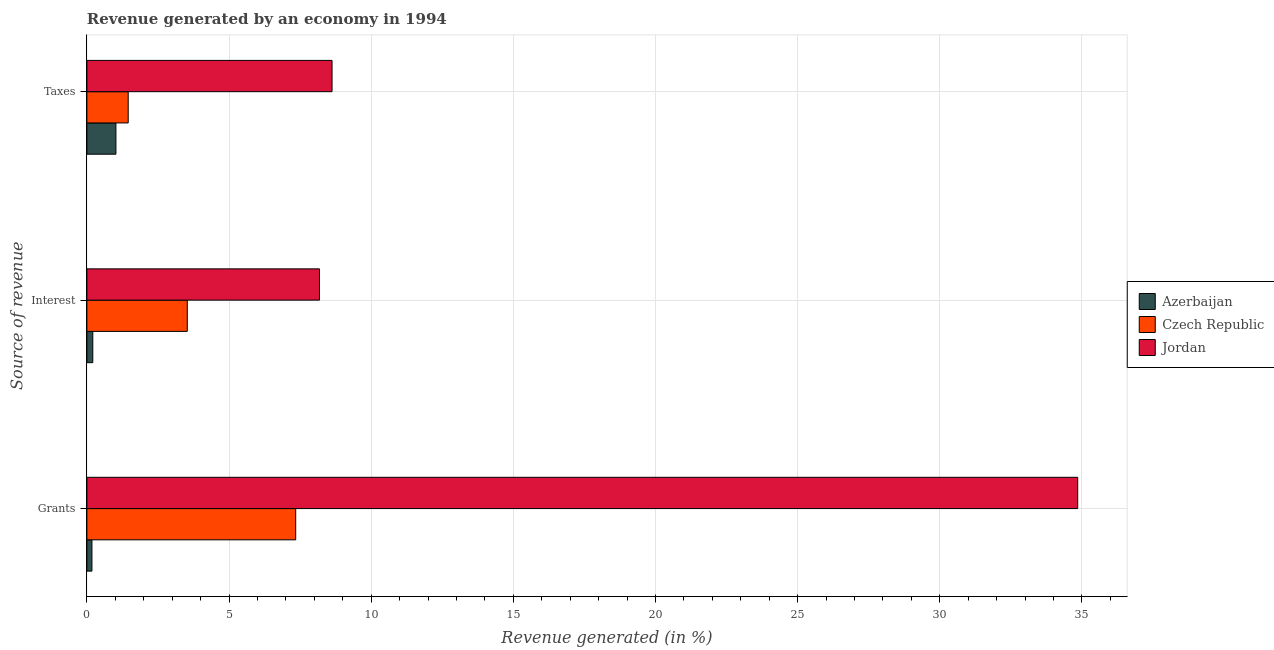How many different coloured bars are there?
Provide a succinct answer. 3. How many groups of bars are there?
Your response must be concise. 3. Are the number of bars per tick equal to the number of legend labels?
Provide a short and direct response. Yes. What is the label of the 3rd group of bars from the top?
Your answer should be compact. Grants. What is the percentage of revenue generated by grants in Jordan?
Provide a short and direct response. 34.85. Across all countries, what is the maximum percentage of revenue generated by interest?
Provide a succinct answer. 8.18. Across all countries, what is the minimum percentage of revenue generated by grants?
Your answer should be compact. 0.18. In which country was the percentage of revenue generated by taxes maximum?
Give a very brief answer. Jordan. In which country was the percentage of revenue generated by taxes minimum?
Keep it short and to the point. Azerbaijan. What is the total percentage of revenue generated by grants in the graph?
Your response must be concise. 42.38. What is the difference between the percentage of revenue generated by grants in Azerbaijan and that in Czech Republic?
Your response must be concise. -7.17. What is the difference between the percentage of revenue generated by taxes in Jordan and the percentage of revenue generated by grants in Azerbaijan?
Your answer should be very brief. 8.45. What is the average percentage of revenue generated by grants per country?
Ensure brevity in your answer.  14.13. What is the difference between the percentage of revenue generated by taxes and percentage of revenue generated by grants in Jordan?
Your answer should be compact. -26.23. In how many countries, is the percentage of revenue generated by taxes greater than 20 %?
Your response must be concise. 0. What is the ratio of the percentage of revenue generated by grants in Jordan to that in Czech Republic?
Provide a short and direct response. 4.74. Is the percentage of revenue generated by taxes in Czech Republic less than that in Jordan?
Ensure brevity in your answer.  Yes. What is the difference between the highest and the second highest percentage of revenue generated by interest?
Ensure brevity in your answer.  4.65. What is the difference between the highest and the lowest percentage of revenue generated by grants?
Offer a very short reply. 34.68. Is the sum of the percentage of revenue generated by interest in Czech Republic and Azerbaijan greater than the maximum percentage of revenue generated by taxes across all countries?
Provide a succinct answer. No. What does the 2nd bar from the top in Grants represents?
Offer a very short reply. Czech Republic. What does the 2nd bar from the bottom in Interest represents?
Your response must be concise. Czech Republic. How many bars are there?
Your response must be concise. 9. Are the values on the major ticks of X-axis written in scientific E-notation?
Your answer should be compact. No. Where does the legend appear in the graph?
Your response must be concise. Center right. How many legend labels are there?
Your answer should be compact. 3. What is the title of the graph?
Offer a terse response. Revenue generated by an economy in 1994. Does "Isle of Man" appear as one of the legend labels in the graph?
Your response must be concise. No. What is the label or title of the X-axis?
Make the answer very short. Revenue generated (in %). What is the label or title of the Y-axis?
Ensure brevity in your answer.  Source of revenue. What is the Revenue generated (in %) of Azerbaijan in Grants?
Your response must be concise. 0.18. What is the Revenue generated (in %) of Czech Republic in Grants?
Provide a short and direct response. 7.35. What is the Revenue generated (in %) in Jordan in Grants?
Your response must be concise. 34.85. What is the Revenue generated (in %) in Azerbaijan in Interest?
Keep it short and to the point. 0.21. What is the Revenue generated (in %) in Czech Republic in Interest?
Your response must be concise. 3.53. What is the Revenue generated (in %) of Jordan in Interest?
Keep it short and to the point. 8.18. What is the Revenue generated (in %) in Azerbaijan in Taxes?
Your response must be concise. 1.02. What is the Revenue generated (in %) in Czech Republic in Taxes?
Your response must be concise. 1.45. What is the Revenue generated (in %) in Jordan in Taxes?
Offer a very short reply. 8.62. Across all Source of revenue, what is the maximum Revenue generated (in %) in Azerbaijan?
Your answer should be very brief. 1.02. Across all Source of revenue, what is the maximum Revenue generated (in %) in Czech Republic?
Your response must be concise. 7.35. Across all Source of revenue, what is the maximum Revenue generated (in %) of Jordan?
Ensure brevity in your answer.  34.85. Across all Source of revenue, what is the minimum Revenue generated (in %) in Azerbaijan?
Offer a very short reply. 0.18. Across all Source of revenue, what is the minimum Revenue generated (in %) of Czech Republic?
Make the answer very short. 1.45. Across all Source of revenue, what is the minimum Revenue generated (in %) of Jordan?
Make the answer very short. 8.18. What is the total Revenue generated (in %) of Azerbaijan in the graph?
Your answer should be very brief. 1.41. What is the total Revenue generated (in %) in Czech Republic in the graph?
Offer a very short reply. 12.33. What is the total Revenue generated (in %) of Jordan in the graph?
Make the answer very short. 51.66. What is the difference between the Revenue generated (in %) in Azerbaijan in Grants and that in Interest?
Ensure brevity in your answer.  -0.03. What is the difference between the Revenue generated (in %) of Czech Republic in Grants and that in Interest?
Offer a very short reply. 3.81. What is the difference between the Revenue generated (in %) in Jordan in Grants and that in Interest?
Provide a succinct answer. 26.67. What is the difference between the Revenue generated (in %) of Azerbaijan in Grants and that in Taxes?
Your response must be concise. -0.84. What is the difference between the Revenue generated (in %) of Czech Republic in Grants and that in Taxes?
Ensure brevity in your answer.  5.89. What is the difference between the Revenue generated (in %) of Jordan in Grants and that in Taxes?
Your response must be concise. 26.23. What is the difference between the Revenue generated (in %) in Azerbaijan in Interest and that in Taxes?
Provide a short and direct response. -0.81. What is the difference between the Revenue generated (in %) of Czech Republic in Interest and that in Taxes?
Offer a very short reply. 2.08. What is the difference between the Revenue generated (in %) of Jordan in Interest and that in Taxes?
Give a very brief answer. -0.44. What is the difference between the Revenue generated (in %) in Azerbaijan in Grants and the Revenue generated (in %) in Czech Republic in Interest?
Give a very brief answer. -3.35. What is the difference between the Revenue generated (in %) in Azerbaijan in Grants and the Revenue generated (in %) in Jordan in Interest?
Make the answer very short. -8. What is the difference between the Revenue generated (in %) of Czech Republic in Grants and the Revenue generated (in %) of Jordan in Interest?
Provide a short and direct response. -0.84. What is the difference between the Revenue generated (in %) in Azerbaijan in Grants and the Revenue generated (in %) in Czech Republic in Taxes?
Keep it short and to the point. -1.28. What is the difference between the Revenue generated (in %) in Azerbaijan in Grants and the Revenue generated (in %) in Jordan in Taxes?
Your answer should be compact. -8.45. What is the difference between the Revenue generated (in %) in Czech Republic in Grants and the Revenue generated (in %) in Jordan in Taxes?
Provide a succinct answer. -1.28. What is the difference between the Revenue generated (in %) in Azerbaijan in Interest and the Revenue generated (in %) in Czech Republic in Taxes?
Offer a terse response. -1.25. What is the difference between the Revenue generated (in %) of Azerbaijan in Interest and the Revenue generated (in %) of Jordan in Taxes?
Your answer should be compact. -8.42. What is the difference between the Revenue generated (in %) in Czech Republic in Interest and the Revenue generated (in %) in Jordan in Taxes?
Ensure brevity in your answer.  -5.09. What is the average Revenue generated (in %) in Azerbaijan per Source of revenue?
Make the answer very short. 0.47. What is the average Revenue generated (in %) of Czech Republic per Source of revenue?
Give a very brief answer. 4.11. What is the average Revenue generated (in %) in Jordan per Source of revenue?
Provide a succinct answer. 17.22. What is the difference between the Revenue generated (in %) in Azerbaijan and Revenue generated (in %) in Czech Republic in Grants?
Ensure brevity in your answer.  -7.17. What is the difference between the Revenue generated (in %) of Azerbaijan and Revenue generated (in %) of Jordan in Grants?
Make the answer very short. -34.68. What is the difference between the Revenue generated (in %) in Czech Republic and Revenue generated (in %) in Jordan in Grants?
Make the answer very short. -27.51. What is the difference between the Revenue generated (in %) in Azerbaijan and Revenue generated (in %) in Czech Republic in Interest?
Keep it short and to the point. -3.32. What is the difference between the Revenue generated (in %) of Azerbaijan and Revenue generated (in %) of Jordan in Interest?
Keep it short and to the point. -7.97. What is the difference between the Revenue generated (in %) of Czech Republic and Revenue generated (in %) of Jordan in Interest?
Make the answer very short. -4.65. What is the difference between the Revenue generated (in %) of Azerbaijan and Revenue generated (in %) of Czech Republic in Taxes?
Make the answer very short. -0.43. What is the difference between the Revenue generated (in %) in Azerbaijan and Revenue generated (in %) in Jordan in Taxes?
Offer a terse response. -7.6. What is the difference between the Revenue generated (in %) of Czech Republic and Revenue generated (in %) of Jordan in Taxes?
Your answer should be very brief. -7.17. What is the ratio of the Revenue generated (in %) of Azerbaijan in Grants to that in Interest?
Offer a very short reply. 0.85. What is the ratio of the Revenue generated (in %) in Czech Republic in Grants to that in Interest?
Your response must be concise. 2.08. What is the ratio of the Revenue generated (in %) of Jordan in Grants to that in Interest?
Offer a terse response. 4.26. What is the ratio of the Revenue generated (in %) of Azerbaijan in Grants to that in Taxes?
Keep it short and to the point. 0.17. What is the ratio of the Revenue generated (in %) in Czech Republic in Grants to that in Taxes?
Keep it short and to the point. 5.05. What is the ratio of the Revenue generated (in %) of Jordan in Grants to that in Taxes?
Provide a succinct answer. 4.04. What is the ratio of the Revenue generated (in %) of Azerbaijan in Interest to that in Taxes?
Provide a succinct answer. 0.2. What is the ratio of the Revenue generated (in %) of Czech Republic in Interest to that in Taxes?
Ensure brevity in your answer.  2.43. What is the ratio of the Revenue generated (in %) in Jordan in Interest to that in Taxes?
Your answer should be compact. 0.95. What is the difference between the highest and the second highest Revenue generated (in %) of Azerbaijan?
Offer a very short reply. 0.81. What is the difference between the highest and the second highest Revenue generated (in %) of Czech Republic?
Give a very brief answer. 3.81. What is the difference between the highest and the second highest Revenue generated (in %) in Jordan?
Your response must be concise. 26.23. What is the difference between the highest and the lowest Revenue generated (in %) of Azerbaijan?
Your answer should be compact. 0.84. What is the difference between the highest and the lowest Revenue generated (in %) in Czech Republic?
Give a very brief answer. 5.89. What is the difference between the highest and the lowest Revenue generated (in %) in Jordan?
Your answer should be compact. 26.67. 